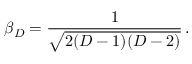Convert formula to latex. <formula><loc_0><loc_0><loc_500><loc_500>\beta _ { D } = \frac { 1 } { \sqrt { 2 ( D - 1 ) ( D - 2 ) } } \, .</formula> 